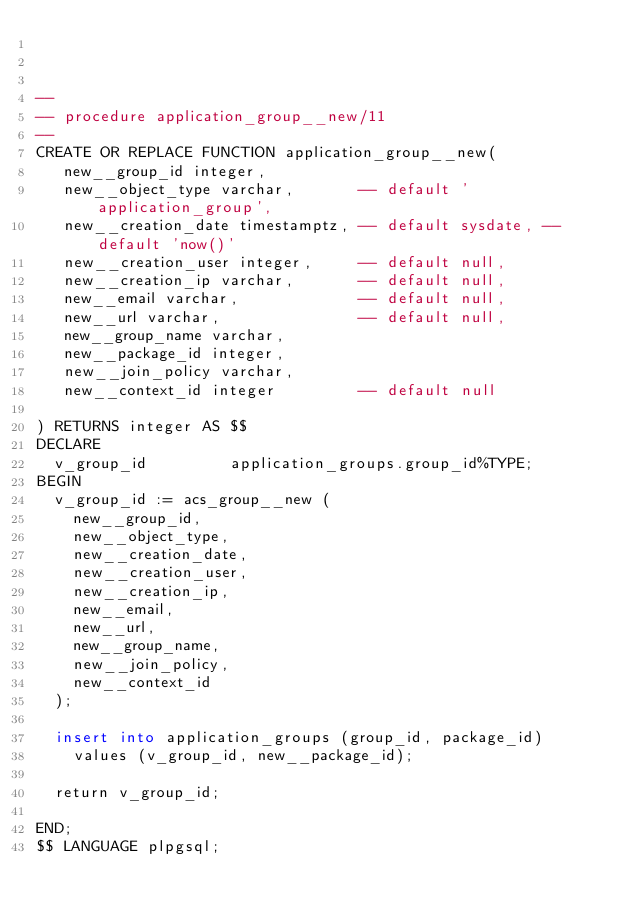Convert code to text. <code><loc_0><loc_0><loc_500><loc_500><_SQL_>


--
-- procedure application_group__new/11
--
CREATE OR REPLACE FUNCTION application_group__new(
   new__group_id integer,
   new__object_type varchar,       -- default 'application_group',
   new__creation_date timestamptz, -- default sysdate, -- default 'now()'
   new__creation_user integer,     -- default null,
   new__creation_ip varchar,       -- default null,
   new__email varchar,             -- default null,
   new__url varchar,               -- default null,
   new__group_name varchar,
   new__package_id integer,
   new__join_policy varchar,
   new__context_id integer         -- default null

) RETURNS integer AS $$
DECLARE
  v_group_id		     application_groups.group_id%TYPE;
BEGIN
  v_group_id := acs_group__new (
    new__group_id,
    new__object_type,
    new__creation_date,
    new__creation_user,
    new__creation_ip,
    new__email,
    new__url,
    new__group_name,
    new__join_policy,
    new__context_id
  );

  insert into application_groups (group_id, package_id) 
    values (v_group_id, new__package_id);

  return v_group_id;

END;
$$ LANGUAGE plpgsql;

</code> 